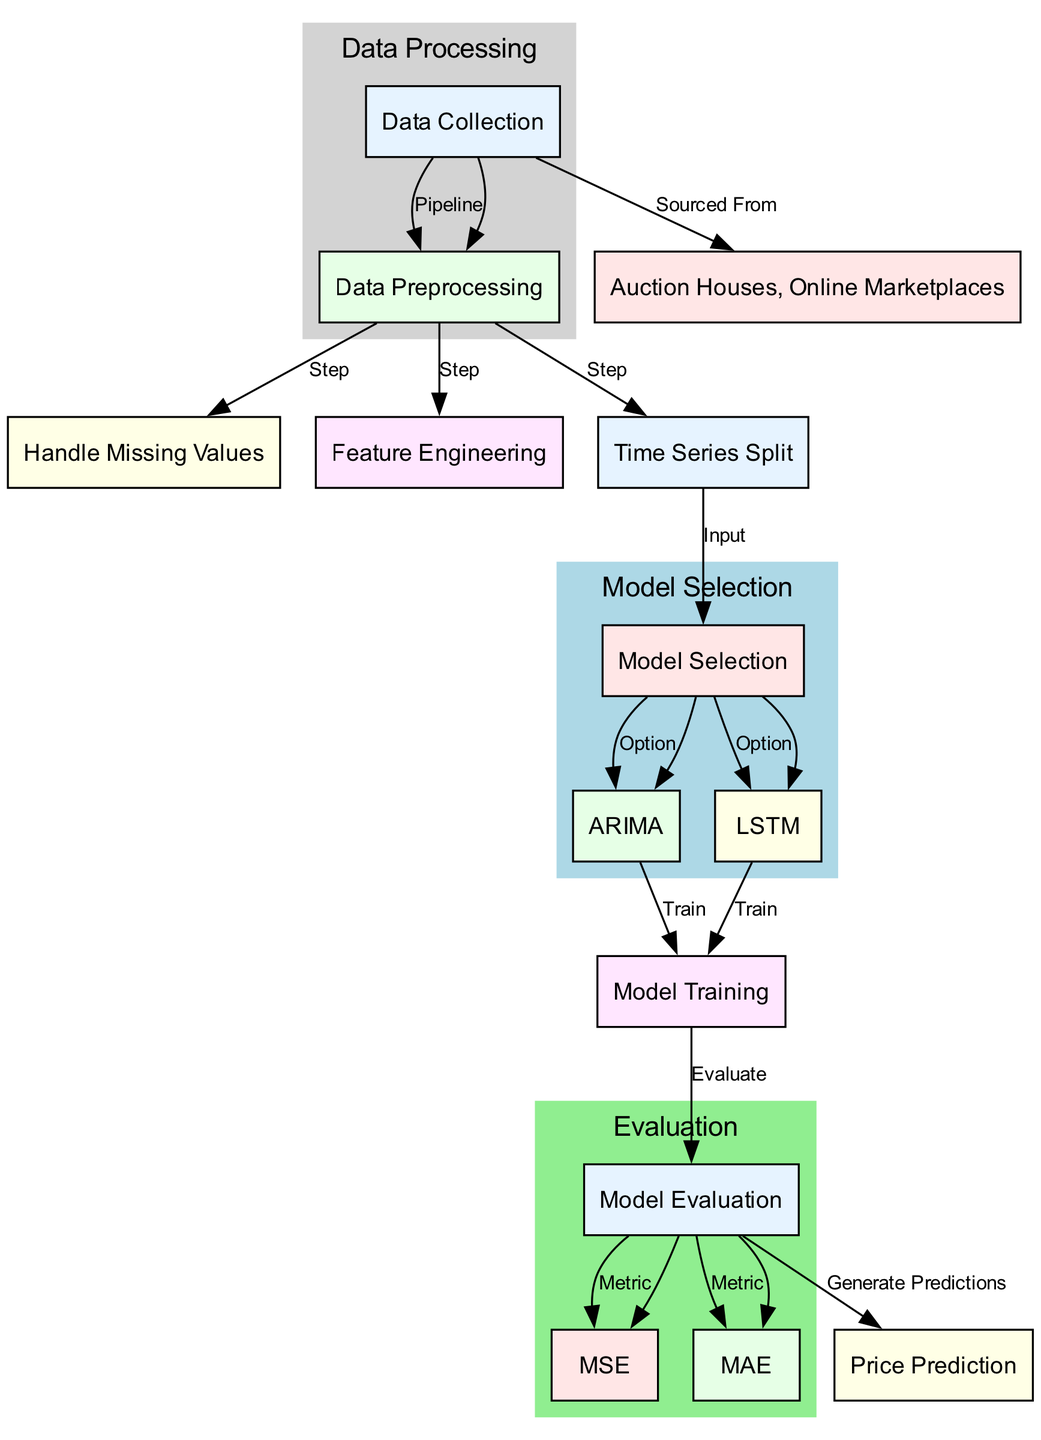What are the data sources for collection? The diagram shows that data collection is sourced from auction houses and online marketplaces, which are indicated as nodes connected to the data collection node.
Answer: Auction Houses, Online Marketplaces What is the first step after data collection? According to the diagram, after data collection, the next step in the pipeline is data preprocessing, which is directly connected to the data collection node.
Answer: Data Preprocessing How many options are there for model selection? The diagram illustrates that there are two options available under model selection, which are ARIMA and LSTM, as indicated by the edges leading from the model selection node.
Answer: Two What metrics are used for model evaluation? The diagram lists two metrics connected to the model evaluation node, namely MSE and MAE, showing the criteria used for assessing the model's performance.
Answer: MSE, MAE What follows after model training? The diagram shows that once the model training is completed, the next step is model evaluation, indicating the progression from training to evaluation in the workflow.
Answer: Model Evaluation Which model option is connected to model training first? The diagram demonstrates that both ARIMA and LSTM lead to model training; however, ARIMA appears first in the flow, showing it is processed before LSTM in this scenario.
Answer: ARIMA What happens after model evaluation? According to the diagram, after model evaluation, the result is price prediction, indicating that the evaluation phase directly feeds into generating predictions.
Answer: Price Prediction What is done to handle missing values? The diagram specifies that handling missing values is a distinct step within the data preprocessing phase, highlighting its importance in preparing data for analysis.
Answer: Handle Missing Values What type of analysis is being conducted in the diagram? The diagram focuses on time series analysis, which is indicated through the various steps leading to the prediction of price trends based on historical data.
Answer: Time Series Analysis 